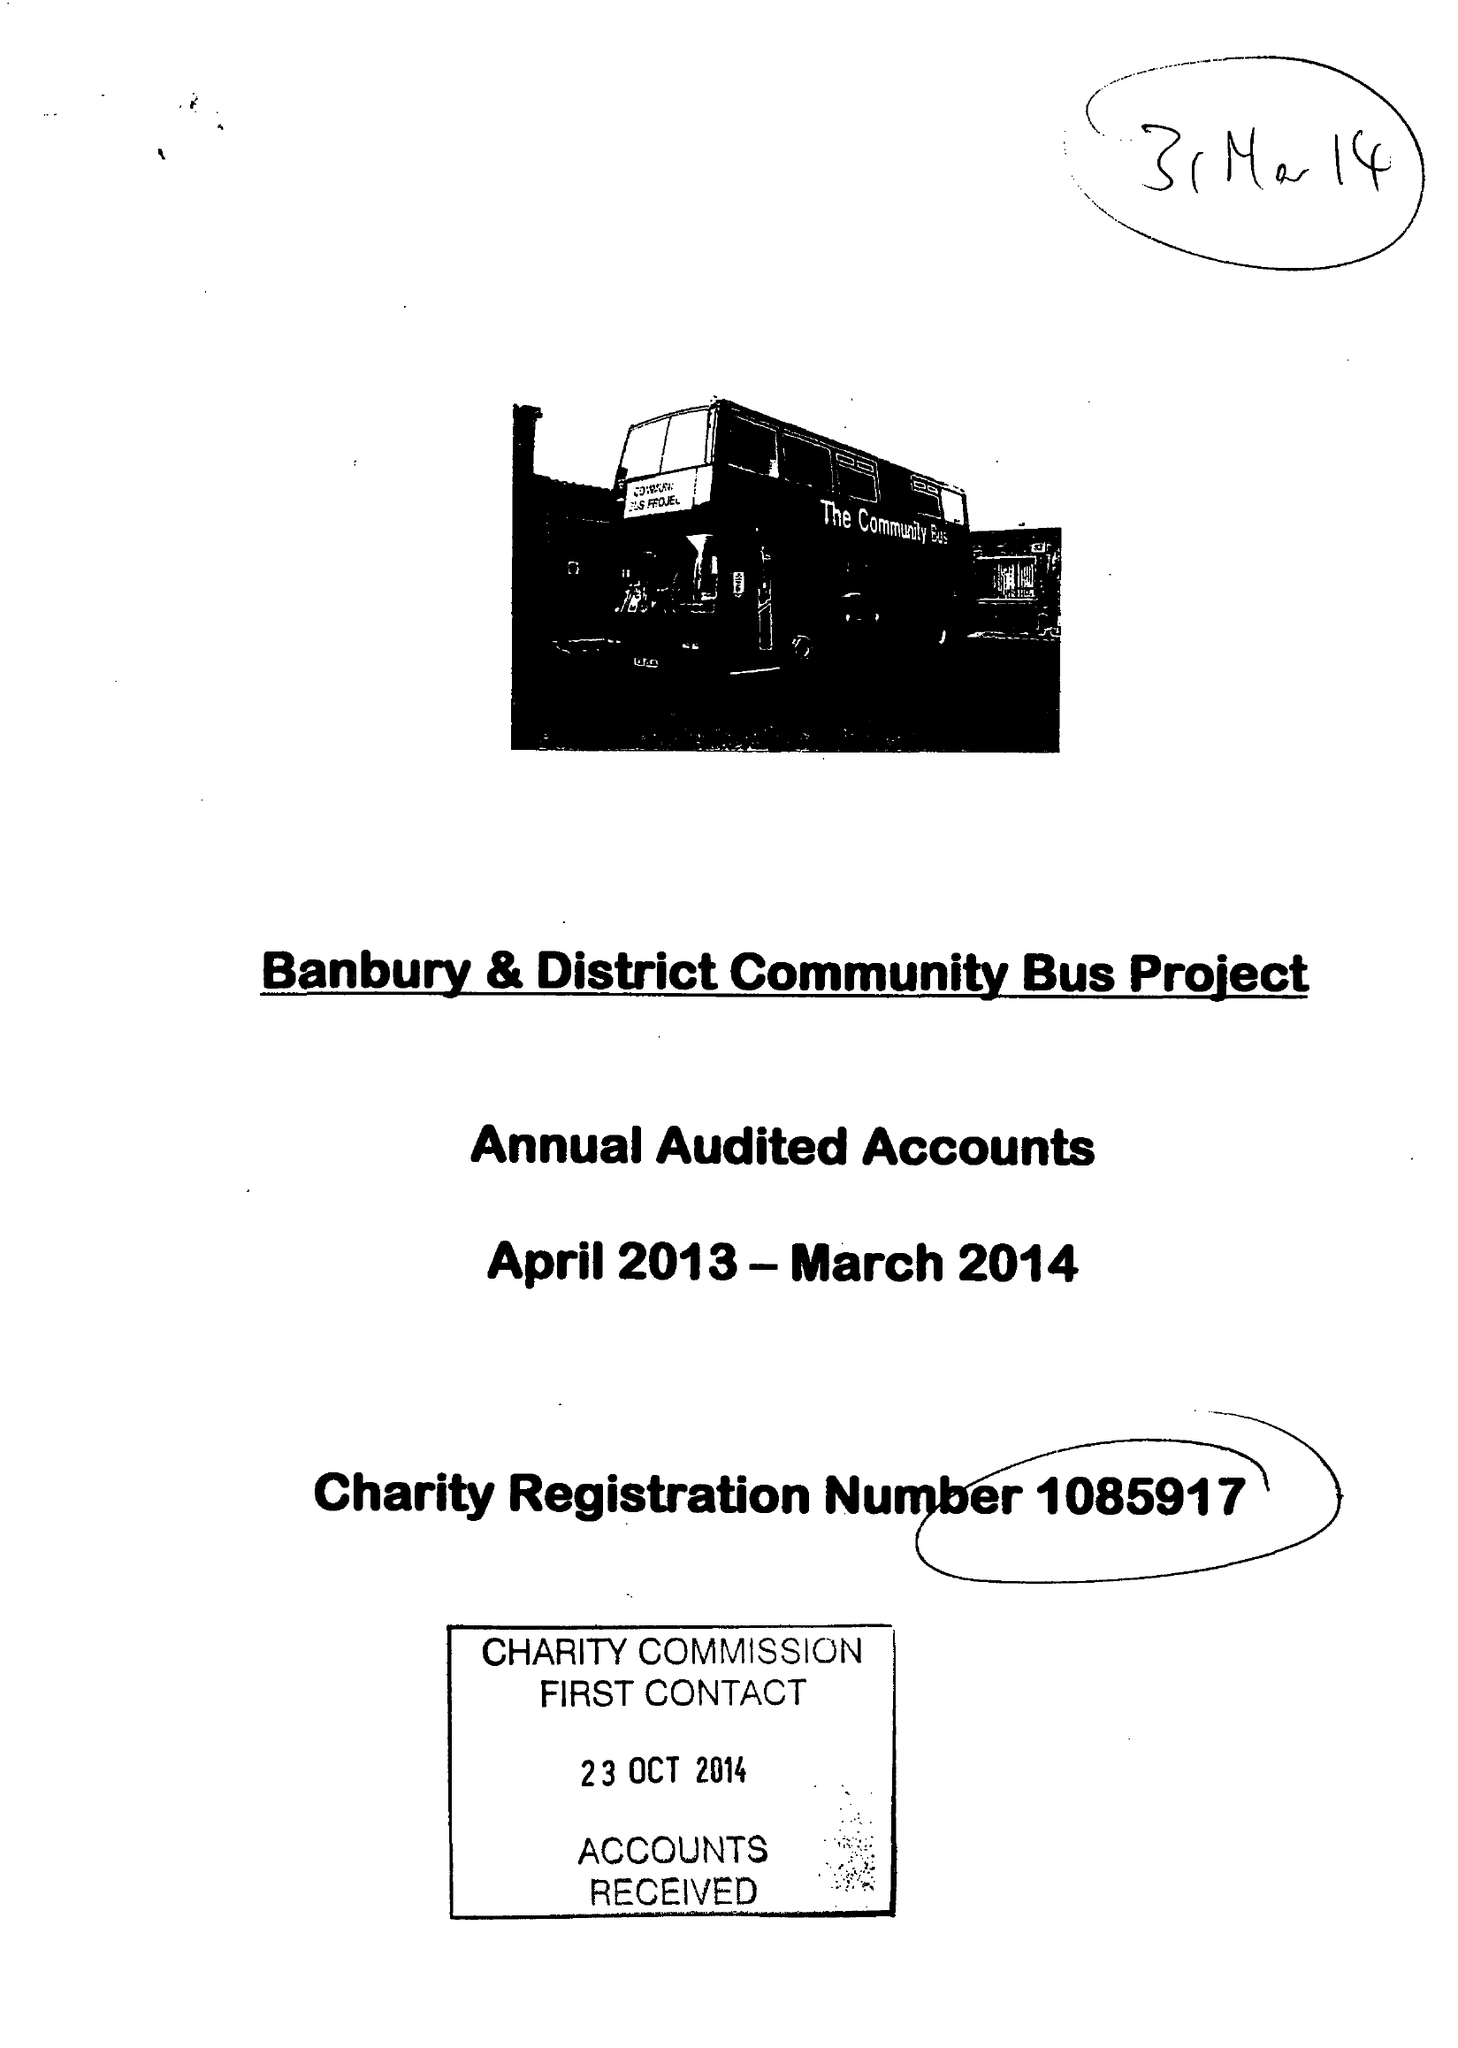What is the value for the charity_name?
Answer the question using a single word or phrase. Banbury and District Community Bus Project 